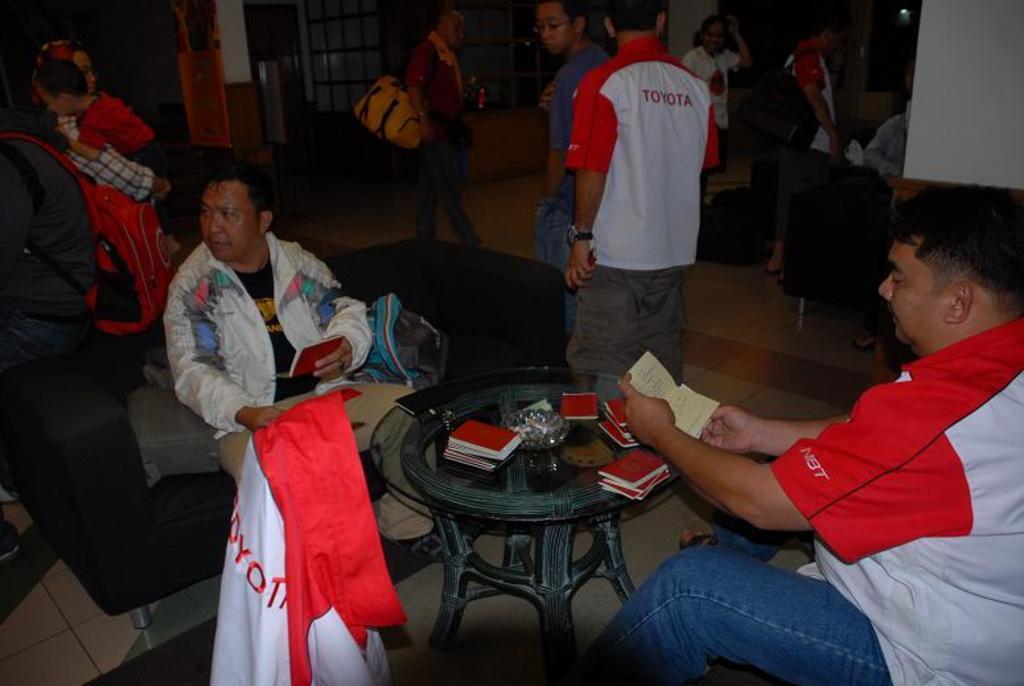In one or two sentences, can you explain what this image depicts? In this picture we can see some group of people where some are sitting on sofa and some are walking and some are standing and in front of them there is table and on table we can see books,bowl, mobile. 